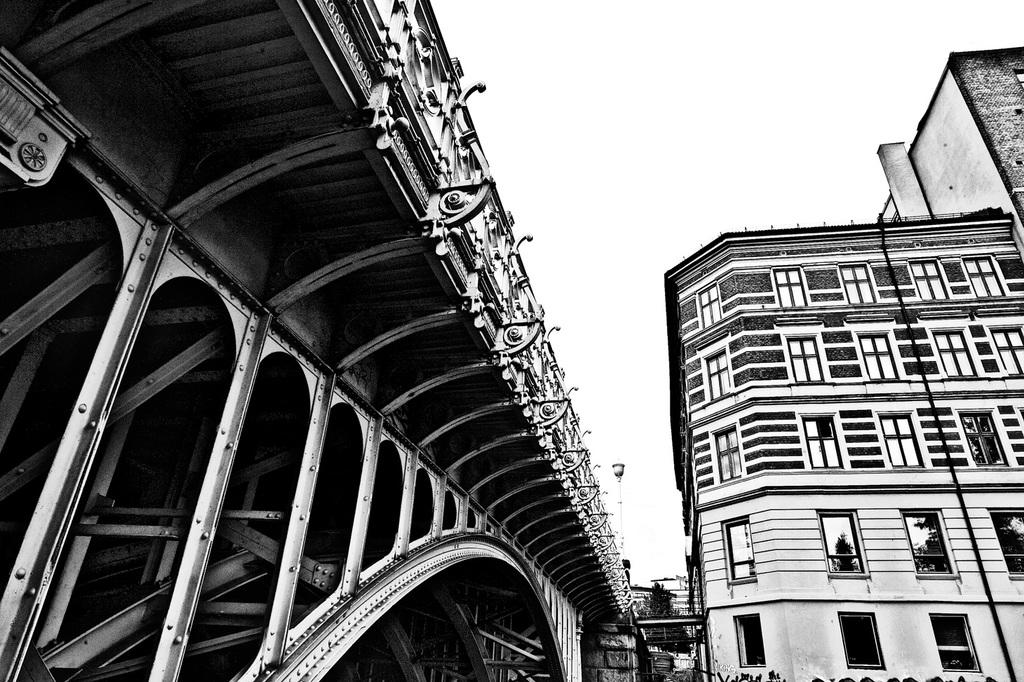What is the color scheme of the image? The image is black and white. Where was the image taken? The image was taken outdoors. What can be seen at the top of the image? The sky is visible at the top of the image. What type of structures are present in the image? There are buildings in the image. What kind of bridge is depicted in the image? There is a bridge with many iron bars in the image. How many sacks of grain are being transported on the bridge in the image? There are no sacks of grain present in the image; it features a bridge with iron bars. What point is being made by the image? The image does not make a point or convey a message; it is a visual representation of a bridge and its surroundings. 